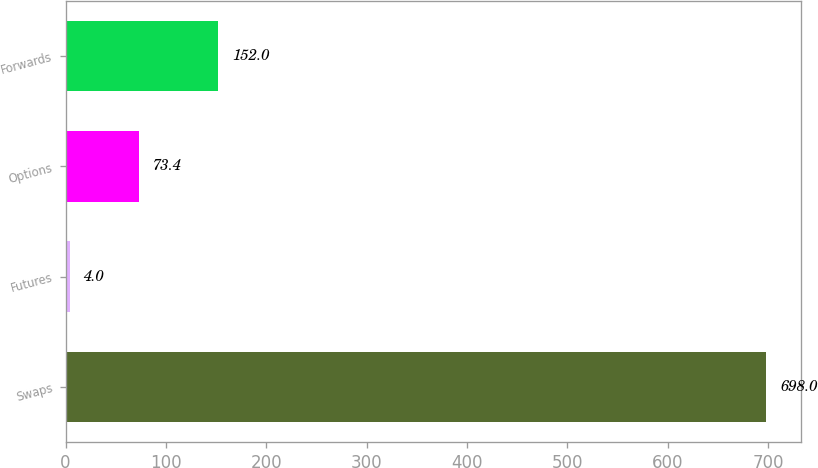Convert chart to OTSL. <chart><loc_0><loc_0><loc_500><loc_500><bar_chart><fcel>Swaps<fcel>Futures<fcel>Options<fcel>Forwards<nl><fcel>698<fcel>4<fcel>73.4<fcel>152<nl></chart> 